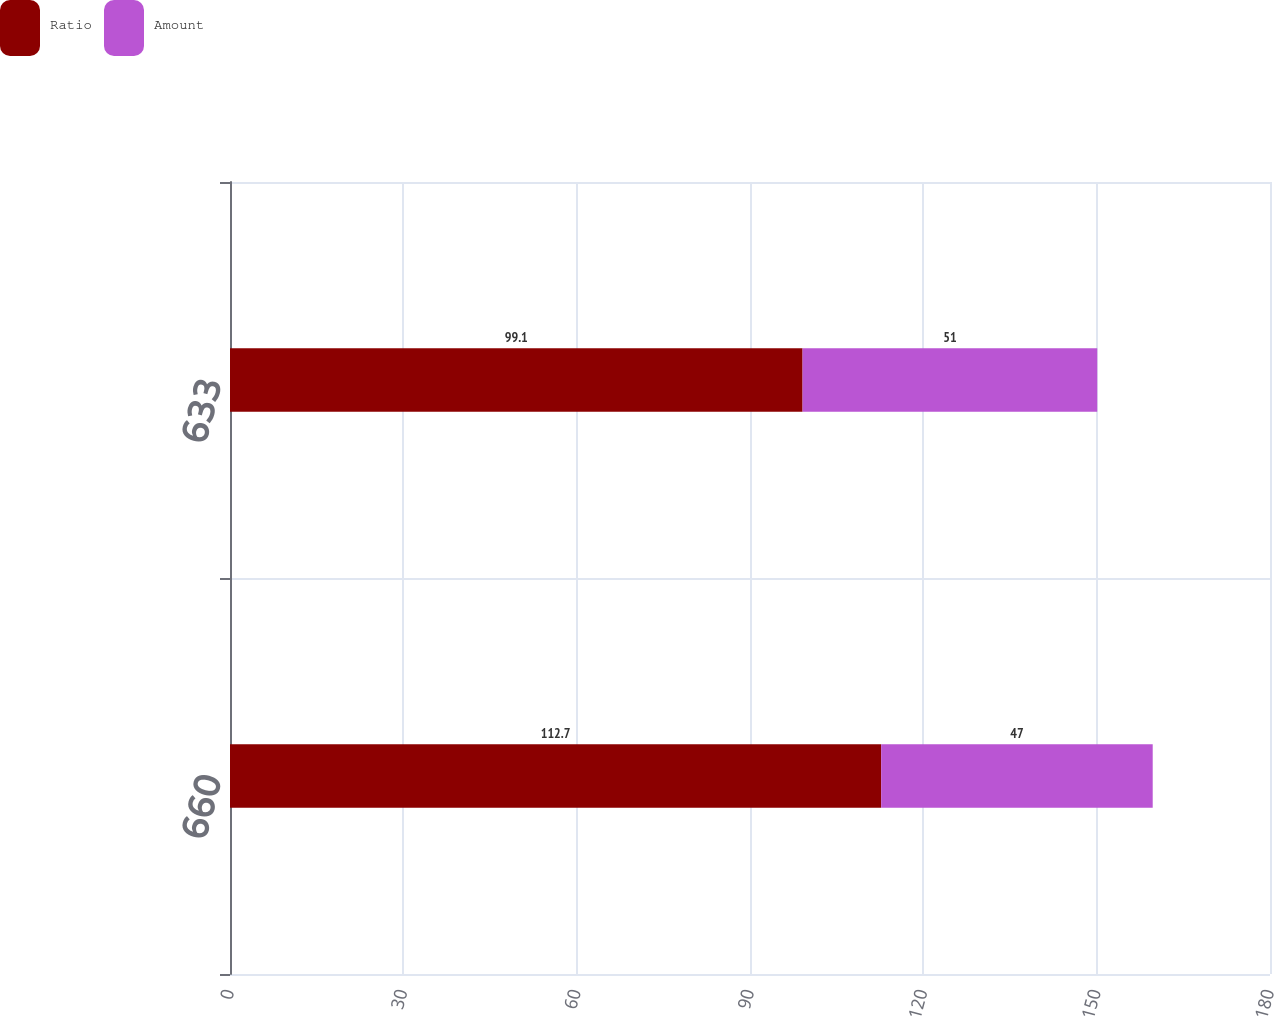Convert chart to OTSL. <chart><loc_0><loc_0><loc_500><loc_500><stacked_bar_chart><ecel><fcel>660<fcel>633<nl><fcel>Ratio<fcel>112.7<fcel>99.1<nl><fcel>Amount<fcel>47<fcel>51<nl></chart> 